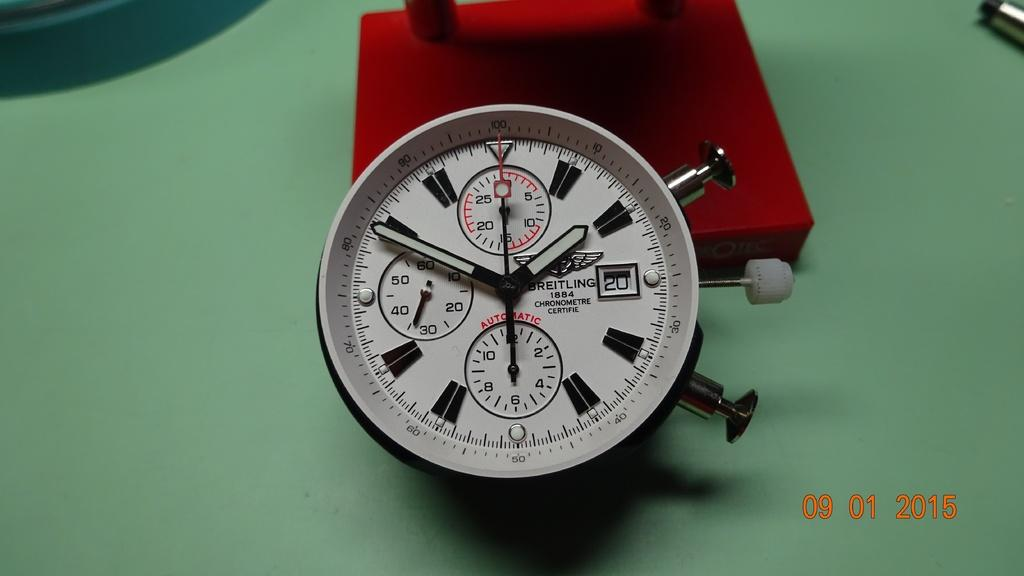<image>
Describe the image concisely. A Breitling watch has the date 1884 on the face. 